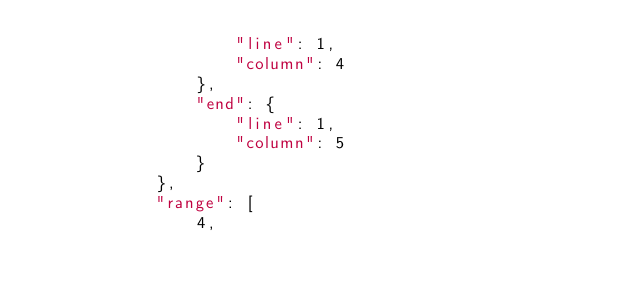<code> <loc_0><loc_0><loc_500><loc_500><_JavaScript_>                    "line": 1,
                    "column": 4
                },
                "end": {
                    "line": 1,
                    "column": 5
                }
            },
            "range": [
                4,</code> 